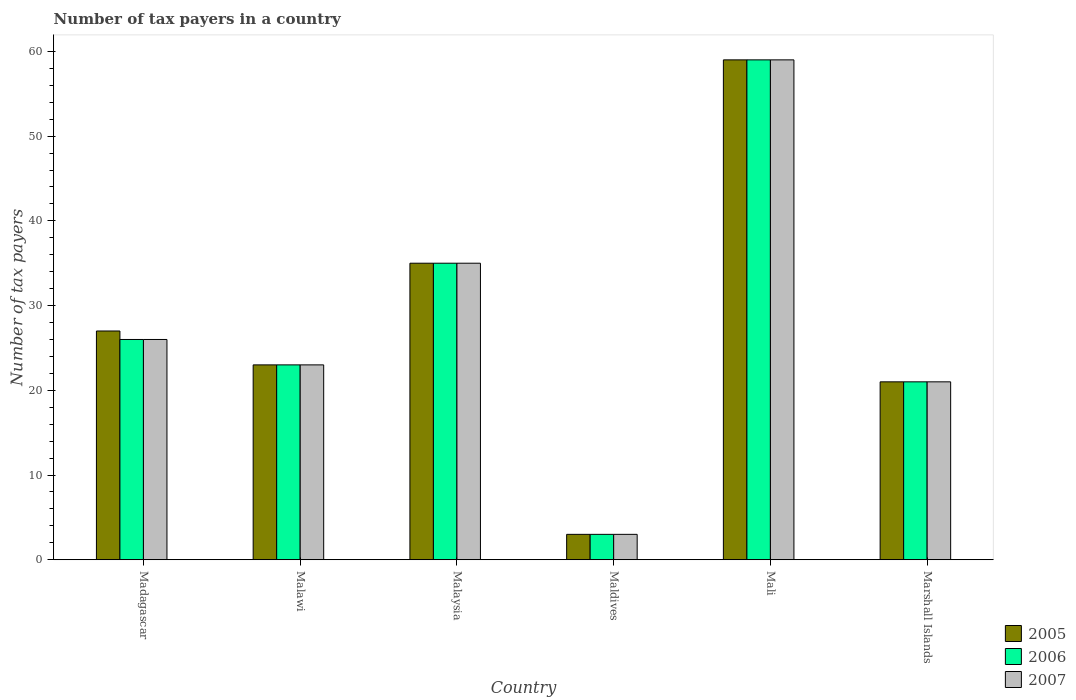How many different coloured bars are there?
Provide a succinct answer. 3. What is the label of the 2nd group of bars from the left?
Ensure brevity in your answer.  Malawi. In how many cases, is the number of bars for a given country not equal to the number of legend labels?
Keep it short and to the point. 0. In which country was the number of tax payers in in 2007 maximum?
Provide a short and direct response. Mali. In which country was the number of tax payers in in 2005 minimum?
Your response must be concise. Maldives. What is the total number of tax payers in in 2006 in the graph?
Provide a short and direct response. 167. What is the difference between the number of tax payers in in 2005 in Madagascar and the number of tax payers in in 2006 in Maldives?
Your answer should be very brief. 24. What is the average number of tax payers in in 2006 per country?
Your answer should be very brief. 27.83. In how many countries, is the number of tax payers in in 2005 greater than 18?
Your response must be concise. 5. What is the ratio of the number of tax payers in in 2006 in Malaysia to that in Mali?
Your response must be concise. 0.59. Is the difference between the number of tax payers in in 2005 in Madagascar and Marshall Islands greater than the difference between the number of tax payers in in 2006 in Madagascar and Marshall Islands?
Your answer should be compact. Yes. What is the difference between the highest and the second highest number of tax payers in in 2006?
Provide a succinct answer. 9. What does the 1st bar from the right in Marshall Islands represents?
Ensure brevity in your answer.  2007. Is it the case that in every country, the sum of the number of tax payers in in 2007 and number of tax payers in in 2005 is greater than the number of tax payers in in 2006?
Offer a very short reply. Yes. How many bars are there?
Provide a succinct answer. 18. Are all the bars in the graph horizontal?
Give a very brief answer. No. Are the values on the major ticks of Y-axis written in scientific E-notation?
Make the answer very short. No. Does the graph contain any zero values?
Provide a succinct answer. No. Does the graph contain grids?
Your answer should be very brief. No. How many legend labels are there?
Your answer should be very brief. 3. What is the title of the graph?
Provide a succinct answer. Number of tax payers in a country. Does "1965" appear as one of the legend labels in the graph?
Provide a short and direct response. No. What is the label or title of the X-axis?
Give a very brief answer. Country. What is the label or title of the Y-axis?
Offer a very short reply. Number of tax payers. What is the Number of tax payers of 2006 in Madagascar?
Offer a terse response. 26. What is the Number of tax payers of 2006 in Malawi?
Provide a short and direct response. 23. What is the Number of tax payers in 2006 in Malaysia?
Offer a very short reply. 35. What is the Number of tax payers of 2005 in Maldives?
Offer a terse response. 3. What is the Number of tax payers in 2006 in Maldives?
Your response must be concise. 3. What is the Number of tax payers of 2006 in Marshall Islands?
Your answer should be compact. 21. What is the Number of tax payers of 2007 in Marshall Islands?
Provide a short and direct response. 21. Across all countries, what is the maximum Number of tax payers of 2006?
Ensure brevity in your answer.  59. Across all countries, what is the maximum Number of tax payers of 2007?
Ensure brevity in your answer.  59. Across all countries, what is the minimum Number of tax payers in 2007?
Your response must be concise. 3. What is the total Number of tax payers in 2005 in the graph?
Your answer should be compact. 168. What is the total Number of tax payers in 2006 in the graph?
Offer a very short reply. 167. What is the total Number of tax payers in 2007 in the graph?
Keep it short and to the point. 167. What is the difference between the Number of tax payers of 2005 in Madagascar and that in Malawi?
Offer a terse response. 4. What is the difference between the Number of tax payers of 2006 in Madagascar and that in Malawi?
Give a very brief answer. 3. What is the difference between the Number of tax payers in 2007 in Madagascar and that in Malawi?
Your response must be concise. 3. What is the difference between the Number of tax payers in 2005 in Madagascar and that in Malaysia?
Ensure brevity in your answer.  -8. What is the difference between the Number of tax payers of 2006 in Madagascar and that in Malaysia?
Keep it short and to the point. -9. What is the difference between the Number of tax payers in 2007 in Madagascar and that in Malaysia?
Give a very brief answer. -9. What is the difference between the Number of tax payers of 2006 in Madagascar and that in Maldives?
Offer a terse response. 23. What is the difference between the Number of tax payers in 2007 in Madagascar and that in Maldives?
Provide a short and direct response. 23. What is the difference between the Number of tax payers in 2005 in Madagascar and that in Mali?
Your response must be concise. -32. What is the difference between the Number of tax payers of 2006 in Madagascar and that in Mali?
Keep it short and to the point. -33. What is the difference between the Number of tax payers in 2007 in Madagascar and that in Mali?
Give a very brief answer. -33. What is the difference between the Number of tax payers in 2006 in Madagascar and that in Marshall Islands?
Give a very brief answer. 5. What is the difference between the Number of tax payers of 2005 in Malawi and that in Malaysia?
Give a very brief answer. -12. What is the difference between the Number of tax payers in 2006 in Malawi and that in Malaysia?
Give a very brief answer. -12. What is the difference between the Number of tax payers in 2005 in Malawi and that in Maldives?
Your answer should be very brief. 20. What is the difference between the Number of tax payers of 2006 in Malawi and that in Maldives?
Offer a very short reply. 20. What is the difference between the Number of tax payers in 2007 in Malawi and that in Maldives?
Make the answer very short. 20. What is the difference between the Number of tax payers in 2005 in Malawi and that in Mali?
Ensure brevity in your answer.  -36. What is the difference between the Number of tax payers of 2006 in Malawi and that in Mali?
Offer a terse response. -36. What is the difference between the Number of tax payers of 2007 in Malawi and that in Mali?
Offer a terse response. -36. What is the difference between the Number of tax payers in 2005 in Malaysia and that in Maldives?
Provide a succinct answer. 32. What is the difference between the Number of tax payers in 2007 in Malaysia and that in Maldives?
Provide a succinct answer. 32. What is the difference between the Number of tax payers of 2005 in Malaysia and that in Mali?
Give a very brief answer. -24. What is the difference between the Number of tax payers in 2006 in Malaysia and that in Mali?
Give a very brief answer. -24. What is the difference between the Number of tax payers of 2007 in Malaysia and that in Mali?
Provide a short and direct response. -24. What is the difference between the Number of tax payers of 2006 in Malaysia and that in Marshall Islands?
Offer a terse response. 14. What is the difference between the Number of tax payers in 2005 in Maldives and that in Mali?
Provide a short and direct response. -56. What is the difference between the Number of tax payers in 2006 in Maldives and that in Mali?
Make the answer very short. -56. What is the difference between the Number of tax payers in 2007 in Maldives and that in Mali?
Give a very brief answer. -56. What is the difference between the Number of tax payers of 2006 in Maldives and that in Marshall Islands?
Your response must be concise. -18. What is the difference between the Number of tax payers in 2007 in Maldives and that in Marshall Islands?
Offer a terse response. -18. What is the difference between the Number of tax payers of 2005 in Mali and that in Marshall Islands?
Provide a short and direct response. 38. What is the difference between the Number of tax payers in 2006 in Madagascar and the Number of tax payers in 2007 in Malawi?
Your answer should be compact. 3. What is the difference between the Number of tax payers in 2005 in Madagascar and the Number of tax payers in 2006 in Malaysia?
Give a very brief answer. -8. What is the difference between the Number of tax payers in 2006 in Madagascar and the Number of tax payers in 2007 in Malaysia?
Offer a terse response. -9. What is the difference between the Number of tax payers in 2005 in Madagascar and the Number of tax payers in 2007 in Maldives?
Keep it short and to the point. 24. What is the difference between the Number of tax payers of 2005 in Madagascar and the Number of tax payers of 2006 in Mali?
Your answer should be very brief. -32. What is the difference between the Number of tax payers of 2005 in Madagascar and the Number of tax payers of 2007 in Mali?
Provide a succinct answer. -32. What is the difference between the Number of tax payers in 2006 in Madagascar and the Number of tax payers in 2007 in Mali?
Make the answer very short. -33. What is the difference between the Number of tax payers in 2005 in Madagascar and the Number of tax payers in 2006 in Marshall Islands?
Your answer should be compact. 6. What is the difference between the Number of tax payers in 2005 in Madagascar and the Number of tax payers in 2007 in Marshall Islands?
Your answer should be very brief. 6. What is the difference between the Number of tax payers in 2005 in Malawi and the Number of tax payers in 2006 in Maldives?
Your answer should be compact. 20. What is the difference between the Number of tax payers of 2005 in Malawi and the Number of tax payers of 2007 in Maldives?
Your answer should be compact. 20. What is the difference between the Number of tax payers of 2005 in Malawi and the Number of tax payers of 2006 in Mali?
Ensure brevity in your answer.  -36. What is the difference between the Number of tax payers in 2005 in Malawi and the Number of tax payers in 2007 in Mali?
Your answer should be very brief. -36. What is the difference between the Number of tax payers of 2006 in Malawi and the Number of tax payers of 2007 in Mali?
Your response must be concise. -36. What is the difference between the Number of tax payers of 2005 in Malawi and the Number of tax payers of 2006 in Marshall Islands?
Keep it short and to the point. 2. What is the difference between the Number of tax payers in 2005 in Malawi and the Number of tax payers in 2007 in Marshall Islands?
Make the answer very short. 2. What is the difference between the Number of tax payers in 2006 in Malawi and the Number of tax payers in 2007 in Marshall Islands?
Offer a very short reply. 2. What is the difference between the Number of tax payers of 2005 in Malaysia and the Number of tax payers of 2006 in Maldives?
Ensure brevity in your answer.  32. What is the difference between the Number of tax payers of 2006 in Malaysia and the Number of tax payers of 2007 in Mali?
Give a very brief answer. -24. What is the difference between the Number of tax payers of 2005 in Malaysia and the Number of tax payers of 2007 in Marshall Islands?
Give a very brief answer. 14. What is the difference between the Number of tax payers in 2005 in Maldives and the Number of tax payers in 2006 in Mali?
Ensure brevity in your answer.  -56. What is the difference between the Number of tax payers of 2005 in Maldives and the Number of tax payers of 2007 in Mali?
Keep it short and to the point. -56. What is the difference between the Number of tax payers in 2006 in Maldives and the Number of tax payers in 2007 in Mali?
Provide a succinct answer. -56. What is the difference between the Number of tax payers in 2005 in Maldives and the Number of tax payers in 2006 in Marshall Islands?
Make the answer very short. -18. What is the difference between the Number of tax payers of 2006 in Maldives and the Number of tax payers of 2007 in Marshall Islands?
Ensure brevity in your answer.  -18. What is the difference between the Number of tax payers in 2005 in Mali and the Number of tax payers in 2006 in Marshall Islands?
Ensure brevity in your answer.  38. What is the difference between the Number of tax payers in 2005 in Mali and the Number of tax payers in 2007 in Marshall Islands?
Provide a short and direct response. 38. What is the difference between the Number of tax payers in 2006 in Mali and the Number of tax payers in 2007 in Marshall Islands?
Provide a short and direct response. 38. What is the average Number of tax payers in 2005 per country?
Keep it short and to the point. 28. What is the average Number of tax payers of 2006 per country?
Ensure brevity in your answer.  27.83. What is the average Number of tax payers in 2007 per country?
Give a very brief answer. 27.83. What is the difference between the Number of tax payers in 2005 and Number of tax payers in 2007 in Madagascar?
Offer a very short reply. 1. What is the difference between the Number of tax payers in 2005 and Number of tax payers in 2007 in Malawi?
Your response must be concise. 0. What is the difference between the Number of tax payers in 2006 and Number of tax payers in 2007 in Malawi?
Your response must be concise. 0. What is the difference between the Number of tax payers in 2005 and Number of tax payers in 2006 in Malaysia?
Your answer should be compact. 0. What is the difference between the Number of tax payers in 2005 and Number of tax payers in 2006 in Maldives?
Your answer should be compact. 0. What is the difference between the Number of tax payers of 2005 and Number of tax payers of 2007 in Mali?
Your response must be concise. 0. What is the difference between the Number of tax payers in 2005 and Number of tax payers in 2006 in Marshall Islands?
Make the answer very short. 0. What is the difference between the Number of tax payers of 2005 and Number of tax payers of 2007 in Marshall Islands?
Provide a short and direct response. 0. What is the ratio of the Number of tax payers in 2005 in Madagascar to that in Malawi?
Your answer should be compact. 1.17. What is the ratio of the Number of tax payers in 2006 in Madagascar to that in Malawi?
Your response must be concise. 1.13. What is the ratio of the Number of tax payers of 2007 in Madagascar to that in Malawi?
Offer a terse response. 1.13. What is the ratio of the Number of tax payers in 2005 in Madagascar to that in Malaysia?
Your answer should be compact. 0.77. What is the ratio of the Number of tax payers in 2006 in Madagascar to that in Malaysia?
Provide a short and direct response. 0.74. What is the ratio of the Number of tax payers of 2007 in Madagascar to that in Malaysia?
Your answer should be very brief. 0.74. What is the ratio of the Number of tax payers in 2005 in Madagascar to that in Maldives?
Offer a very short reply. 9. What is the ratio of the Number of tax payers in 2006 in Madagascar to that in Maldives?
Ensure brevity in your answer.  8.67. What is the ratio of the Number of tax payers of 2007 in Madagascar to that in Maldives?
Offer a terse response. 8.67. What is the ratio of the Number of tax payers of 2005 in Madagascar to that in Mali?
Provide a short and direct response. 0.46. What is the ratio of the Number of tax payers of 2006 in Madagascar to that in Mali?
Ensure brevity in your answer.  0.44. What is the ratio of the Number of tax payers of 2007 in Madagascar to that in Mali?
Offer a terse response. 0.44. What is the ratio of the Number of tax payers in 2005 in Madagascar to that in Marshall Islands?
Your answer should be compact. 1.29. What is the ratio of the Number of tax payers in 2006 in Madagascar to that in Marshall Islands?
Your answer should be compact. 1.24. What is the ratio of the Number of tax payers of 2007 in Madagascar to that in Marshall Islands?
Your response must be concise. 1.24. What is the ratio of the Number of tax payers in 2005 in Malawi to that in Malaysia?
Offer a very short reply. 0.66. What is the ratio of the Number of tax payers in 2006 in Malawi to that in Malaysia?
Ensure brevity in your answer.  0.66. What is the ratio of the Number of tax payers of 2007 in Malawi to that in Malaysia?
Keep it short and to the point. 0.66. What is the ratio of the Number of tax payers of 2005 in Malawi to that in Maldives?
Your response must be concise. 7.67. What is the ratio of the Number of tax payers in 2006 in Malawi to that in Maldives?
Keep it short and to the point. 7.67. What is the ratio of the Number of tax payers of 2007 in Malawi to that in Maldives?
Keep it short and to the point. 7.67. What is the ratio of the Number of tax payers in 2005 in Malawi to that in Mali?
Your answer should be very brief. 0.39. What is the ratio of the Number of tax payers of 2006 in Malawi to that in Mali?
Provide a succinct answer. 0.39. What is the ratio of the Number of tax payers of 2007 in Malawi to that in Mali?
Ensure brevity in your answer.  0.39. What is the ratio of the Number of tax payers in 2005 in Malawi to that in Marshall Islands?
Give a very brief answer. 1.1. What is the ratio of the Number of tax payers of 2006 in Malawi to that in Marshall Islands?
Offer a terse response. 1.1. What is the ratio of the Number of tax payers in 2007 in Malawi to that in Marshall Islands?
Give a very brief answer. 1.1. What is the ratio of the Number of tax payers in 2005 in Malaysia to that in Maldives?
Provide a short and direct response. 11.67. What is the ratio of the Number of tax payers of 2006 in Malaysia to that in Maldives?
Your response must be concise. 11.67. What is the ratio of the Number of tax payers in 2007 in Malaysia to that in Maldives?
Offer a terse response. 11.67. What is the ratio of the Number of tax payers in 2005 in Malaysia to that in Mali?
Provide a short and direct response. 0.59. What is the ratio of the Number of tax payers in 2006 in Malaysia to that in Mali?
Your answer should be compact. 0.59. What is the ratio of the Number of tax payers in 2007 in Malaysia to that in Mali?
Ensure brevity in your answer.  0.59. What is the ratio of the Number of tax payers of 2006 in Malaysia to that in Marshall Islands?
Make the answer very short. 1.67. What is the ratio of the Number of tax payers of 2007 in Malaysia to that in Marshall Islands?
Keep it short and to the point. 1.67. What is the ratio of the Number of tax payers of 2005 in Maldives to that in Mali?
Offer a terse response. 0.05. What is the ratio of the Number of tax payers in 2006 in Maldives to that in Mali?
Offer a very short reply. 0.05. What is the ratio of the Number of tax payers of 2007 in Maldives to that in Mali?
Your answer should be compact. 0.05. What is the ratio of the Number of tax payers in 2005 in Maldives to that in Marshall Islands?
Provide a succinct answer. 0.14. What is the ratio of the Number of tax payers of 2006 in Maldives to that in Marshall Islands?
Offer a terse response. 0.14. What is the ratio of the Number of tax payers of 2007 in Maldives to that in Marshall Islands?
Offer a very short reply. 0.14. What is the ratio of the Number of tax payers in 2005 in Mali to that in Marshall Islands?
Offer a terse response. 2.81. What is the ratio of the Number of tax payers of 2006 in Mali to that in Marshall Islands?
Provide a short and direct response. 2.81. What is the ratio of the Number of tax payers in 2007 in Mali to that in Marshall Islands?
Provide a succinct answer. 2.81. What is the difference between the highest and the second highest Number of tax payers in 2005?
Make the answer very short. 24. What is the difference between the highest and the lowest Number of tax payers of 2005?
Your response must be concise. 56. 